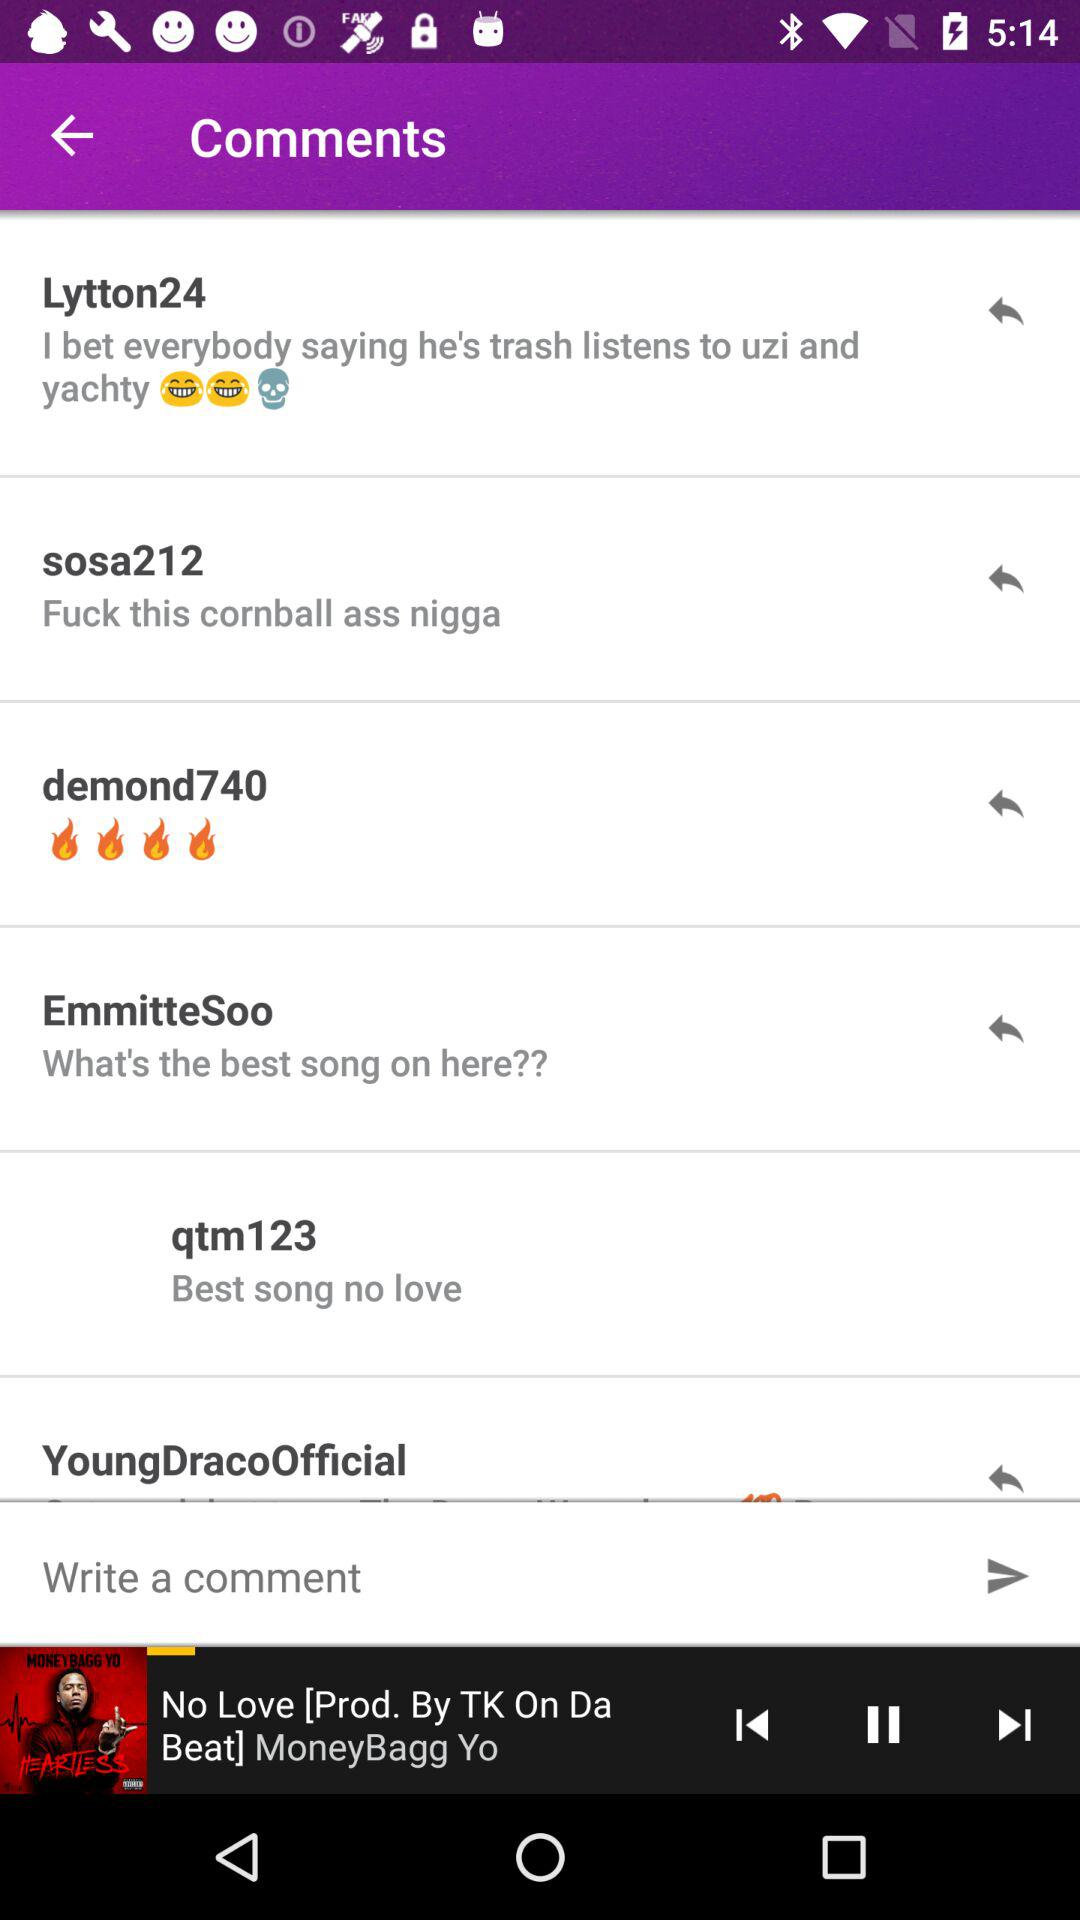How many comments are there for this song?
Answer the question using a single word or phrase. 6 